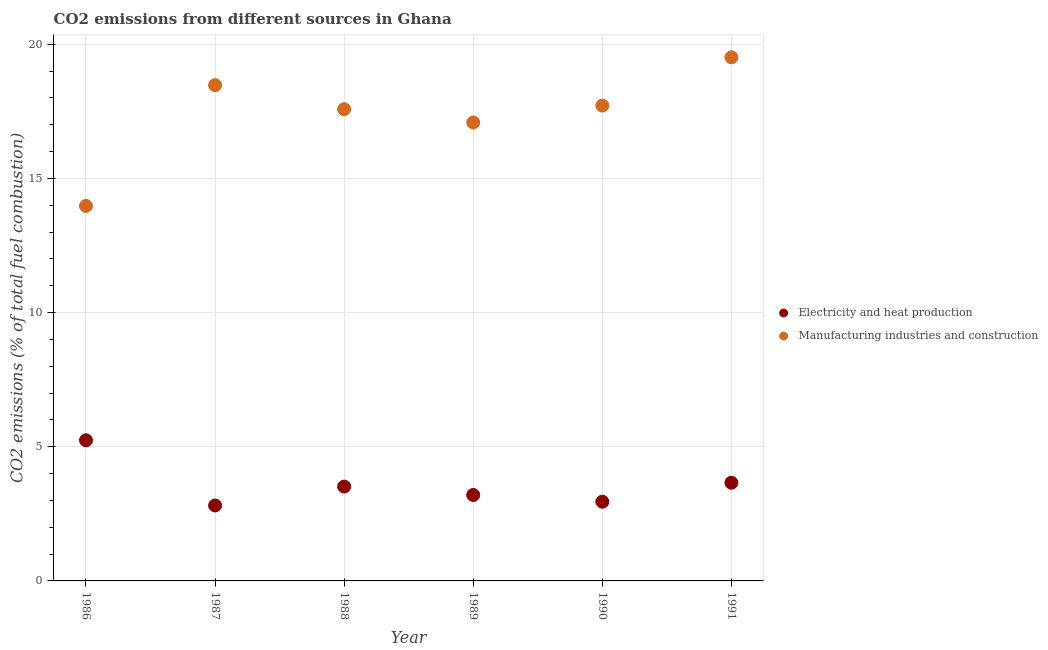How many different coloured dotlines are there?
Keep it short and to the point. 2. What is the co2 emissions due to manufacturing industries in 1989?
Your answer should be very brief. 17.08. Across all years, what is the maximum co2 emissions due to electricity and heat production?
Keep it short and to the point. 5.24. Across all years, what is the minimum co2 emissions due to manufacturing industries?
Your answer should be compact. 13.97. In which year was the co2 emissions due to manufacturing industries maximum?
Offer a very short reply. 1991. In which year was the co2 emissions due to electricity and heat production minimum?
Provide a succinct answer. 1987. What is the total co2 emissions due to manufacturing industries in the graph?
Your answer should be very brief. 104.33. What is the difference between the co2 emissions due to electricity and heat production in 1989 and that in 1990?
Offer a terse response. 0.25. What is the difference between the co2 emissions due to electricity and heat production in 1987 and the co2 emissions due to manufacturing industries in 1991?
Your answer should be very brief. -16.7. What is the average co2 emissions due to electricity and heat production per year?
Offer a terse response. 3.56. In the year 1988, what is the difference between the co2 emissions due to manufacturing industries and co2 emissions due to electricity and heat production?
Ensure brevity in your answer.  14.06. What is the ratio of the co2 emissions due to manufacturing industries in 1987 to that in 1988?
Ensure brevity in your answer.  1.05. Is the co2 emissions due to manufacturing industries in 1989 less than that in 1991?
Your response must be concise. Yes. What is the difference between the highest and the second highest co2 emissions due to manufacturing industries?
Offer a very short reply. 1.04. What is the difference between the highest and the lowest co2 emissions due to electricity and heat production?
Make the answer very short. 2.43. In how many years, is the co2 emissions due to manufacturing industries greater than the average co2 emissions due to manufacturing industries taken over all years?
Your answer should be compact. 4. Is the co2 emissions due to electricity and heat production strictly greater than the co2 emissions due to manufacturing industries over the years?
Provide a short and direct response. No. Is the co2 emissions due to manufacturing industries strictly less than the co2 emissions due to electricity and heat production over the years?
Your answer should be very brief. No. How many dotlines are there?
Your answer should be very brief. 2. How many years are there in the graph?
Ensure brevity in your answer.  6. What is the difference between two consecutive major ticks on the Y-axis?
Provide a short and direct response. 5. Are the values on the major ticks of Y-axis written in scientific E-notation?
Your answer should be very brief. No. Does the graph contain grids?
Provide a succinct answer. Yes. How many legend labels are there?
Provide a short and direct response. 2. What is the title of the graph?
Your response must be concise. CO2 emissions from different sources in Ghana. What is the label or title of the X-axis?
Make the answer very short. Year. What is the label or title of the Y-axis?
Provide a short and direct response. CO2 emissions (% of total fuel combustion). What is the CO2 emissions (% of total fuel combustion) of Electricity and heat production in 1986?
Provide a short and direct response. 5.24. What is the CO2 emissions (% of total fuel combustion) in Manufacturing industries and construction in 1986?
Make the answer very short. 13.97. What is the CO2 emissions (% of total fuel combustion) in Electricity and heat production in 1987?
Offer a terse response. 2.81. What is the CO2 emissions (% of total fuel combustion) of Manufacturing industries and construction in 1987?
Make the answer very short. 18.47. What is the CO2 emissions (% of total fuel combustion) in Electricity and heat production in 1988?
Offer a very short reply. 3.52. What is the CO2 emissions (% of total fuel combustion) in Manufacturing industries and construction in 1988?
Provide a succinct answer. 17.58. What is the CO2 emissions (% of total fuel combustion) in Electricity and heat production in 1989?
Your response must be concise. 3.2. What is the CO2 emissions (% of total fuel combustion) in Manufacturing industries and construction in 1989?
Ensure brevity in your answer.  17.08. What is the CO2 emissions (% of total fuel combustion) of Electricity and heat production in 1990?
Offer a terse response. 2.95. What is the CO2 emissions (% of total fuel combustion) of Manufacturing industries and construction in 1990?
Your response must be concise. 17.71. What is the CO2 emissions (% of total fuel combustion) of Electricity and heat production in 1991?
Offer a terse response. 3.66. What is the CO2 emissions (% of total fuel combustion) of Manufacturing industries and construction in 1991?
Your response must be concise. 19.51. Across all years, what is the maximum CO2 emissions (% of total fuel combustion) of Electricity and heat production?
Ensure brevity in your answer.  5.24. Across all years, what is the maximum CO2 emissions (% of total fuel combustion) of Manufacturing industries and construction?
Your answer should be very brief. 19.51. Across all years, what is the minimum CO2 emissions (% of total fuel combustion) in Electricity and heat production?
Make the answer very short. 2.81. Across all years, what is the minimum CO2 emissions (% of total fuel combustion) in Manufacturing industries and construction?
Make the answer very short. 13.97. What is the total CO2 emissions (% of total fuel combustion) in Electricity and heat production in the graph?
Offer a terse response. 21.38. What is the total CO2 emissions (% of total fuel combustion) in Manufacturing industries and construction in the graph?
Offer a very short reply. 104.33. What is the difference between the CO2 emissions (% of total fuel combustion) of Electricity and heat production in 1986 and that in 1987?
Make the answer very short. 2.43. What is the difference between the CO2 emissions (% of total fuel combustion) of Manufacturing industries and construction in 1986 and that in 1987?
Provide a succinct answer. -4.5. What is the difference between the CO2 emissions (% of total fuel combustion) of Electricity and heat production in 1986 and that in 1988?
Keep it short and to the point. 1.72. What is the difference between the CO2 emissions (% of total fuel combustion) of Manufacturing industries and construction in 1986 and that in 1988?
Provide a short and direct response. -3.6. What is the difference between the CO2 emissions (% of total fuel combustion) in Electricity and heat production in 1986 and that in 1989?
Offer a terse response. 2.04. What is the difference between the CO2 emissions (% of total fuel combustion) of Manufacturing industries and construction in 1986 and that in 1989?
Provide a short and direct response. -3.11. What is the difference between the CO2 emissions (% of total fuel combustion) in Electricity and heat production in 1986 and that in 1990?
Make the answer very short. 2.29. What is the difference between the CO2 emissions (% of total fuel combustion) in Manufacturing industries and construction in 1986 and that in 1990?
Provide a short and direct response. -3.74. What is the difference between the CO2 emissions (% of total fuel combustion) in Electricity and heat production in 1986 and that in 1991?
Your answer should be compact. 1.58. What is the difference between the CO2 emissions (% of total fuel combustion) in Manufacturing industries and construction in 1986 and that in 1991?
Make the answer very short. -5.54. What is the difference between the CO2 emissions (% of total fuel combustion) of Electricity and heat production in 1987 and that in 1988?
Offer a terse response. -0.7. What is the difference between the CO2 emissions (% of total fuel combustion) of Manufacturing industries and construction in 1987 and that in 1988?
Offer a terse response. 0.9. What is the difference between the CO2 emissions (% of total fuel combustion) in Electricity and heat production in 1987 and that in 1989?
Make the answer very short. -0.39. What is the difference between the CO2 emissions (% of total fuel combustion) in Manufacturing industries and construction in 1987 and that in 1989?
Offer a very short reply. 1.39. What is the difference between the CO2 emissions (% of total fuel combustion) of Electricity and heat production in 1987 and that in 1990?
Offer a very short reply. -0.14. What is the difference between the CO2 emissions (% of total fuel combustion) in Manufacturing industries and construction in 1987 and that in 1990?
Give a very brief answer. 0.76. What is the difference between the CO2 emissions (% of total fuel combustion) of Electricity and heat production in 1987 and that in 1991?
Give a very brief answer. -0.85. What is the difference between the CO2 emissions (% of total fuel combustion) of Manufacturing industries and construction in 1987 and that in 1991?
Give a very brief answer. -1.04. What is the difference between the CO2 emissions (% of total fuel combustion) of Electricity and heat production in 1988 and that in 1989?
Offer a very short reply. 0.31. What is the difference between the CO2 emissions (% of total fuel combustion) in Manufacturing industries and construction in 1988 and that in 1989?
Ensure brevity in your answer.  0.5. What is the difference between the CO2 emissions (% of total fuel combustion) of Electricity and heat production in 1988 and that in 1990?
Your answer should be very brief. 0.56. What is the difference between the CO2 emissions (% of total fuel combustion) in Manufacturing industries and construction in 1988 and that in 1990?
Your answer should be compact. -0.13. What is the difference between the CO2 emissions (% of total fuel combustion) in Electricity and heat production in 1988 and that in 1991?
Give a very brief answer. -0.14. What is the difference between the CO2 emissions (% of total fuel combustion) in Manufacturing industries and construction in 1988 and that in 1991?
Ensure brevity in your answer.  -1.93. What is the difference between the CO2 emissions (% of total fuel combustion) of Electricity and heat production in 1989 and that in 1990?
Offer a very short reply. 0.25. What is the difference between the CO2 emissions (% of total fuel combustion) in Manufacturing industries and construction in 1989 and that in 1990?
Make the answer very short. -0.63. What is the difference between the CO2 emissions (% of total fuel combustion) in Electricity and heat production in 1989 and that in 1991?
Your answer should be compact. -0.46. What is the difference between the CO2 emissions (% of total fuel combustion) in Manufacturing industries and construction in 1989 and that in 1991?
Make the answer very short. -2.43. What is the difference between the CO2 emissions (% of total fuel combustion) in Electricity and heat production in 1990 and that in 1991?
Give a very brief answer. -0.71. What is the difference between the CO2 emissions (% of total fuel combustion) in Manufacturing industries and construction in 1990 and that in 1991?
Your answer should be very brief. -1.8. What is the difference between the CO2 emissions (% of total fuel combustion) of Electricity and heat production in 1986 and the CO2 emissions (% of total fuel combustion) of Manufacturing industries and construction in 1987?
Provide a short and direct response. -13.23. What is the difference between the CO2 emissions (% of total fuel combustion) in Electricity and heat production in 1986 and the CO2 emissions (% of total fuel combustion) in Manufacturing industries and construction in 1988?
Your answer should be compact. -12.34. What is the difference between the CO2 emissions (% of total fuel combustion) of Electricity and heat production in 1986 and the CO2 emissions (% of total fuel combustion) of Manufacturing industries and construction in 1989?
Give a very brief answer. -11.84. What is the difference between the CO2 emissions (% of total fuel combustion) in Electricity and heat production in 1986 and the CO2 emissions (% of total fuel combustion) in Manufacturing industries and construction in 1990?
Provide a short and direct response. -12.47. What is the difference between the CO2 emissions (% of total fuel combustion) of Electricity and heat production in 1986 and the CO2 emissions (% of total fuel combustion) of Manufacturing industries and construction in 1991?
Offer a very short reply. -14.27. What is the difference between the CO2 emissions (% of total fuel combustion) in Electricity and heat production in 1987 and the CO2 emissions (% of total fuel combustion) in Manufacturing industries and construction in 1988?
Offer a terse response. -14.77. What is the difference between the CO2 emissions (% of total fuel combustion) of Electricity and heat production in 1987 and the CO2 emissions (% of total fuel combustion) of Manufacturing industries and construction in 1989?
Provide a short and direct response. -14.27. What is the difference between the CO2 emissions (% of total fuel combustion) of Electricity and heat production in 1987 and the CO2 emissions (% of total fuel combustion) of Manufacturing industries and construction in 1990?
Keep it short and to the point. -14.9. What is the difference between the CO2 emissions (% of total fuel combustion) in Electricity and heat production in 1987 and the CO2 emissions (% of total fuel combustion) in Manufacturing industries and construction in 1991?
Offer a terse response. -16.7. What is the difference between the CO2 emissions (% of total fuel combustion) of Electricity and heat production in 1988 and the CO2 emissions (% of total fuel combustion) of Manufacturing industries and construction in 1989?
Provide a succinct answer. -13.57. What is the difference between the CO2 emissions (% of total fuel combustion) of Electricity and heat production in 1988 and the CO2 emissions (% of total fuel combustion) of Manufacturing industries and construction in 1990?
Provide a short and direct response. -14.2. What is the difference between the CO2 emissions (% of total fuel combustion) of Electricity and heat production in 1988 and the CO2 emissions (% of total fuel combustion) of Manufacturing industries and construction in 1991?
Give a very brief answer. -16. What is the difference between the CO2 emissions (% of total fuel combustion) of Electricity and heat production in 1989 and the CO2 emissions (% of total fuel combustion) of Manufacturing industries and construction in 1990?
Keep it short and to the point. -14.51. What is the difference between the CO2 emissions (% of total fuel combustion) in Electricity and heat production in 1989 and the CO2 emissions (% of total fuel combustion) in Manufacturing industries and construction in 1991?
Offer a terse response. -16.31. What is the difference between the CO2 emissions (% of total fuel combustion) of Electricity and heat production in 1990 and the CO2 emissions (% of total fuel combustion) of Manufacturing industries and construction in 1991?
Your answer should be very brief. -16.56. What is the average CO2 emissions (% of total fuel combustion) in Electricity and heat production per year?
Provide a succinct answer. 3.56. What is the average CO2 emissions (% of total fuel combustion) in Manufacturing industries and construction per year?
Ensure brevity in your answer.  17.39. In the year 1986, what is the difference between the CO2 emissions (% of total fuel combustion) in Electricity and heat production and CO2 emissions (% of total fuel combustion) in Manufacturing industries and construction?
Your answer should be very brief. -8.73. In the year 1987, what is the difference between the CO2 emissions (% of total fuel combustion) of Electricity and heat production and CO2 emissions (% of total fuel combustion) of Manufacturing industries and construction?
Keep it short and to the point. -15.66. In the year 1988, what is the difference between the CO2 emissions (% of total fuel combustion) of Electricity and heat production and CO2 emissions (% of total fuel combustion) of Manufacturing industries and construction?
Your answer should be compact. -14.06. In the year 1989, what is the difference between the CO2 emissions (% of total fuel combustion) in Electricity and heat production and CO2 emissions (% of total fuel combustion) in Manufacturing industries and construction?
Provide a short and direct response. -13.88. In the year 1990, what is the difference between the CO2 emissions (% of total fuel combustion) of Electricity and heat production and CO2 emissions (% of total fuel combustion) of Manufacturing industries and construction?
Your answer should be compact. -14.76. In the year 1991, what is the difference between the CO2 emissions (% of total fuel combustion) of Electricity and heat production and CO2 emissions (% of total fuel combustion) of Manufacturing industries and construction?
Make the answer very short. -15.85. What is the ratio of the CO2 emissions (% of total fuel combustion) in Electricity and heat production in 1986 to that in 1987?
Your answer should be compact. 1.86. What is the ratio of the CO2 emissions (% of total fuel combustion) of Manufacturing industries and construction in 1986 to that in 1987?
Offer a very short reply. 0.76. What is the ratio of the CO2 emissions (% of total fuel combustion) in Electricity and heat production in 1986 to that in 1988?
Give a very brief answer. 1.49. What is the ratio of the CO2 emissions (% of total fuel combustion) of Manufacturing industries and construction in 1986 to that in 1988?
Your answer should be very brief. 0.8. What is the ratio of the CO2 emissions (% of total fuel combustion) of Electricity and heat production in 1986 to that in 1989?
Offer a very short reply. 1.64. What is the ratio of the CO2 emissions (% of total fuel combustion) of Manufacturing industries and construction in 1986 to that in 1989?
Offer a terse response. 0.82. What is the ratio of the CO2 emissions (% of total fuel combustion) in Electricity and heat production in 1986 to that in 1990?
Your answer should be very brief. 1.78. What is the ratio of the CO2 emissions (% of total fuel combustion) in Manufacturing industries and construction in 1986 to that in 1990?
Offer a very short reply. 0.79. What is the ratio of the CO2 emissions (% of total fuel combustion) in Electricity and heat production in 1986 to that in 1991?
Your answer should be very brief. 1.43. What is the ratio of the CO2 emissions (% of total fuel combustion) of Manufacturing industries and construction in 1986 to that in 1991?
Give a very brief answer. 0.72. What is the ratio of the CO2 emissions (% of total fuel combustion) of Electricity and heat production in 1987 to that in 1988?
Give a very brief answer. 0.8. What is the ratio of the CO2 emissions (% of total fuel combustion) of Manufacturing industries and construction in 1987 to that in 1988?
Provide a succinct answer. 1.05. What is the ratio of the CO2 emissions (% of total fuel combustion) of Electricity and heat production in 1987 to that in 1989?
Give a very brief answer. 0.88. What is the ratio of the CO2 emissions (% of total fuel combustion) in Manufacturing industries and construction in 1987 to that in 1989?
Ensure brevity in your answer.  1.08. What is the ratio of the CO2 emissions (% of total fuel combustion) in Electricity and heat production in 1987 to that in 1990?
Provide a succinct answer. 0.95. What is the ratio of the CO2 emissions (% of total fuel combustion) of Manufacturing industries and construction in 1987 to that in 1990?
Provide a succinct answer. 1.04. What is the ratio of the CO2 emissions (% of total fuel combustion) in Electricity and heat production in 1987 to that in 1991?
Offer a terse response. 0.77. What is the ratio of the CO2 emissions (% of total fuel combustion) in Manufacturing industries and construction in 1987 to that in 1991?
Your answer should be very brief. 0.95. What is the ratio of the CO2 emissions (% of total fuel combustion) in Electricity and heat production in 1988 to that in 1989?
Keep it short and to the point. 1.1. What is the ratio of the CO2 emissions (% of total fuel combustion) of Manufacturing industries and construction in 1988 to that in 1989?
Provide a succinct answer. 1.03. What is the ratio of the CO2 emissions (% of total fuel combustion) of Electricity and heat production in 1988 to that in 1990?
Your response must be concise. 1.19. What is the ratio of the CO2 emissions (% of total fuel combustion) of Manufacturing industries and construction in 1988 to that in 1990?
Provide a short and direct response. 0.99. What is the ratio of the CO2 emissions (% of total fuel combustion) in Electricity and heat production in 1988 to that in 1991?
Provide a short and direct response. 0.96. What is the ratio of the CO2 emissions (% of total fuel combustion) in Manufacturing industries and construction in 1988 to that in 1991?
Give a very brief answer. 0.9. What is the ratio of the CO2 emissions (% of total fuel combustion) in Electricity and heat production in 1989 to that in 1990?
Keep it short and to the point. 1.08. What is the ratio of the CO2 emissions (% of total fuel combustion) in Manufacturing industries and construction in 1989 to that in 1990?
Make the answer very short. 0.96. What is the ratio of the CO2 emissions (% of total fuel combustion) in Electricity and heat production in 1989 to that in 1991?
Provide a short and direct response. 0.88. What is the ratio of the CO2 emissions (% of total fuel combustion) in Manufacturing industries and construction in 1989 to that in 1991?
Your response must be concise. 0.88. What is the ratio of the CO2 emissions (% of total fuel combustion) of Electricity and heat production in 1990 to that in 1991?
Offer a very short reply. 0.81. What is the ratio of the CO2 emissions (% of total fuel combustion) of Manufacturing industries and construction in 1990 to that in 1991?
Keep it short and to the point. 0.91. What is the difference between the highest and the second highest CO2 emissions (% of total fuel combustion) of Electricity and heat production?
Make the answer very short. 1.58. What is the difference between the highest and the second highest CO2 emissions (% of total fuel combustion) of Manufacturing industries and construction?
Give a very brief answer. 1.04. What is the difference between the highest and the lowest CO2 emissions (% of total fuel combustion) of Electricity and heat production?
Offer a very short reply. 2.43. What is the difference between the highest and the lowest CO2 emissions (% of total fuel combustion) in Manufacturing industries and construction?
Offer a very short reply. 5.54. 